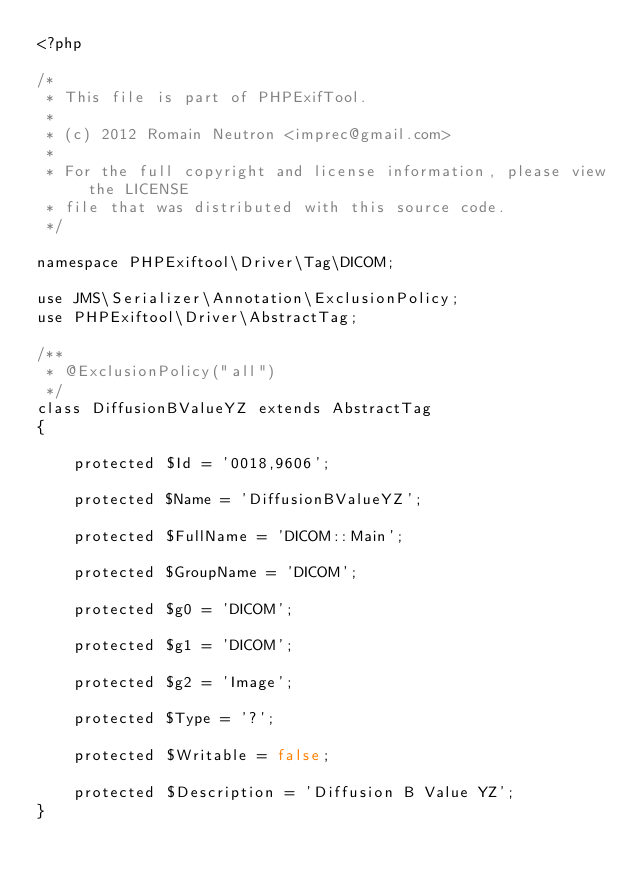<code> <loc_0><loc_0><loc_500><loc_500><_PHP_><?php

/*
 * This file is part of PHPExifTool.
 *
 * (c) 2012 Romain Neutron <imprec@gmail.com>
 *
 * For the full copyright and license information, please view the LICENSE
 * file that was distributed with this source code.
 */

namespace PHPExiftool\Driver\Tag\DICOM;

use JMS\Serializer\Annotation\ExclusionPolicy;
use PHPExiftool\Driver\AbstractTag;

/**
 * @ExclusionPolicy("all")
 */
class DiffusionBValueYZ extends AbstractTag
{

    protected $Id = '0018,9606';

    protected $Name = 'DiffusionBValueYZ';

    protected $FullName = 'DICOM::Main';

    protected $GroupName = 'DICOM';

    protected $g0 = 'DICOM';

    protected $g1 = 'DICOM';

    protected $g2 = 'Image';

    protected $Type = '?';

    protected $Writable = false;

    protected $Description = 'Diffusion B Value YZ';
}
</code> 